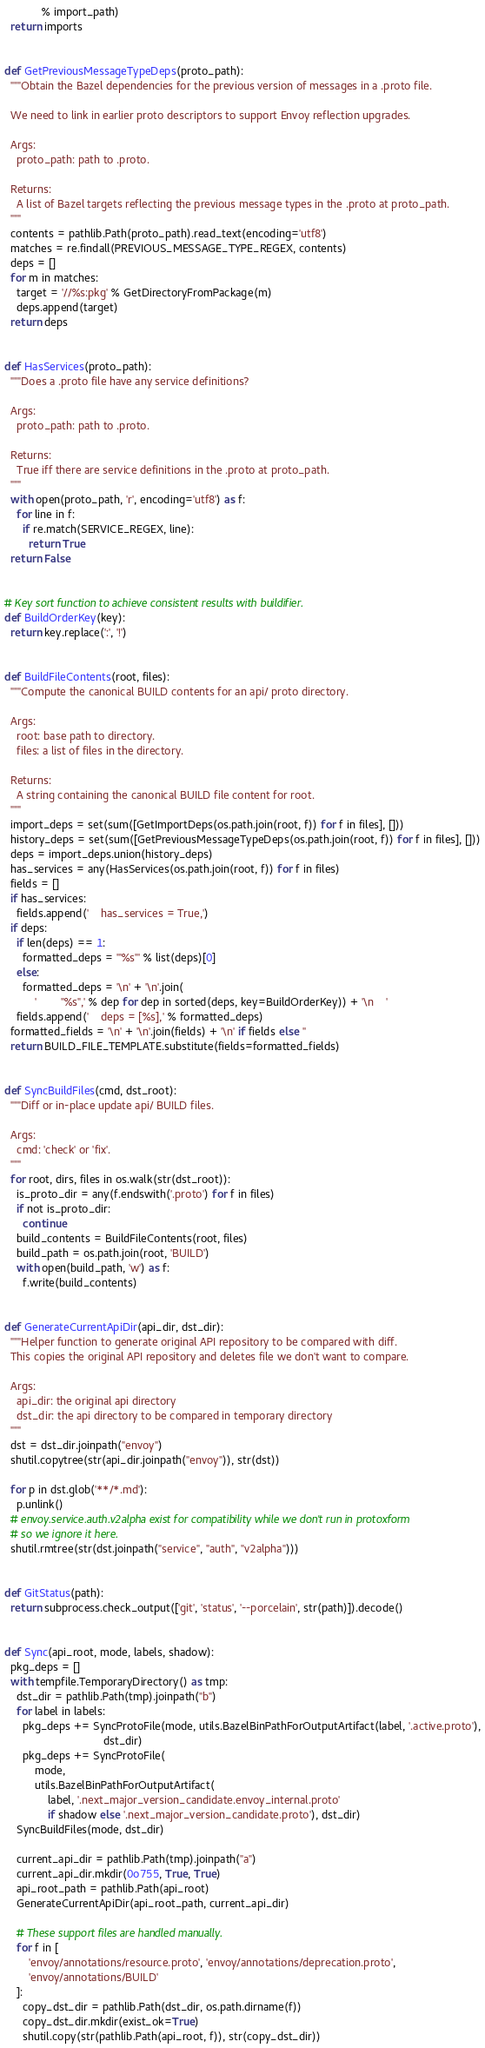<code> <loc_0><loc_0><loc_500><loc_500><_Python_>            % import_path)
  return imports


def GetPreviousMessageTypeDeps(proto_path):
  """Obtain the Bazel dependencies for the previous version of messages in a .proto file.

  We need to link in earlier proto descriptors to support Envoy reflection upgrades.

  Args:
    proto_path: path to .proto.

  Returns:
    A list of Bazel targets reflecting the previous message types in the .proto at proto_path.
  """
  contents = pathlib.Path(proto_path).read_text(encoding='utf8')
  matches = re.findall(PREVIOUS_MESSAGE_TYPE_REGEX, contents)
  deps = []
  for m in matches:
    target = '//%s:pkg' % GetDirectoryFromPackage(m)
    deps.append(target)
  return deps


def HasServices(proto_path):
  """Does a .proto file have any service definitions?

  Args:
    proto_path: path to .proto.

  Returns:
    True iff there are service definitions in the .proto at proto_path.
  """
  with open(proto_path, 'r', encoding='utf8') as f:
    for line in f:
      if re.match(SERVICE_REGEX, line):
        return True
  return False


# Key sort function to achieve consistent results with buildifier.
def BuildOrderKey(key):
  return key.replace(':', '!')


def BuildFileContents(root, files):
  """Compute the canonical BUILD contents for an api/ proto directory.

  Args:
    root: base path to directory.
    files: a list of files in the directory.

  Returns:
    A string containing the canonical BUILD file content for root.
  """
  import_deps = set(sum([GetImportDeps(os.path.join(root, f)) for f in files], []))
  history_deps = set(sum([GetPreviousMessageTypeDeps(os.path.join(root, f)) for f in files], []))
  deps = import_deps.union(history_deps)
  has_services = any(HasServices(os.path.join(root, f)) for f in files)
  fields = []
  if has_services:
    fields.append('    has_services = True,')
  if deps:
    if len(deps) == 1:
      formatted_deps = '"%s"' % list(deps)[0]
    else:
      formatted_deps = '\n' + '\n'.join(
          '        "%s",' % dep for dep in sorted(deps, key=BuildOrderKey)) + '\n    '
    fields.append('    deps = [%s],' % formatted_deps)
  formatted_fields = '\n' + '\n'.join(fields) + '\n' if fields else ''
  return BUILD_FILE_TEMPLATE.substitute(fields=formatted_fields)


def SyncBuildFiles(cmd, dst_root):
  """Diff or in-place update api/ BUILD files.

  Args:
    cmd: 'check' or 'fix'.
  """
  for root, dirs, files in os.walk(str(dst_root)):
    is_proto_dir = any(f.endswith('.proto') for f in files)
    if not is_proto_dir:
      continue
    build_contents = BuildFileContents(root, files)
    build_path = os.path.join(root, 'BUILD')
    with open(build_path, 'w') as f:
      f.write(build_contents)


def GenerateCurrentApiDir(api_dir, dst_dir):
  """Helper function to generate original API repository to be compared with diff.
  This copies the original API repository and deletes file we don't want to compare.

  Args:
    api_dir: the original api directory
    dst_dir: the api directory to be compared in temporary directory
  """
  dst = dst_dir.joinpath("envoy")
  shutil.copytree(str(api_dir.joinpath("envoy")), str(dst))

  for p in dst.glob('**/*.md'):
    p.unlink()
  # envoy.service.auth.v2alpha exist for compatibility while we don't run in protoxform
  # so we ignore it here.
  shutil.rmtree(str(dst.joinpath("service", "auth", "v2alpha")))


def GitStatus(path):
  return subprocess.check_output(['git', 'status', '--porcelain', str(path)]).decode()


def Sync(api_root, mode, labels, shadow):
  pkg_deps = []
  with tempfile.TemporaryDirectory() as tmp:
    dst_dir = pathlib.Path(tmp).joinpath("b")
    for label in labels:
      pkg_deps += SyncProtoFile(mode, utils.BazelBinPathForOutputArtifact(label, '.active.proto'),
                                dst_dir)
      pkg_deps += SyncProtoFile(
          mode,
          utils.BazelBinPathForOutputArtifact(
              label, '.next_major_version_candidate.envoy_internal.proto'
              if shadow else '.next_major_version_candidate.proto'), dst_dir)
    SyncBuildFiles(mode, dst_dir)

    current_api_dir = pathlib.Path(tmp).joinpath("a")
    current_api_dir.mkdir(0o755, True, True)
    api_root_path = pathlib.Path(api_root)
    GenerateCurrentApiDir(api_root_path, current_api_dir)

    # These support files are handled manually.
    for f in [
        'envoy/annotations/resource.proto', 'envoy/annotations/deprecation.proto',
        'envoy/annotations/BUILD'
    ]:
      copy_dst_dir = pathlib.Path(dst_dir, os.path.dirname(f))
      copy_dst_dir.mkdir(exist_ok=True)
      shutil.copy(str(pathlib.Path(api_root, f)), str(copy_dst_dir))
</code> 